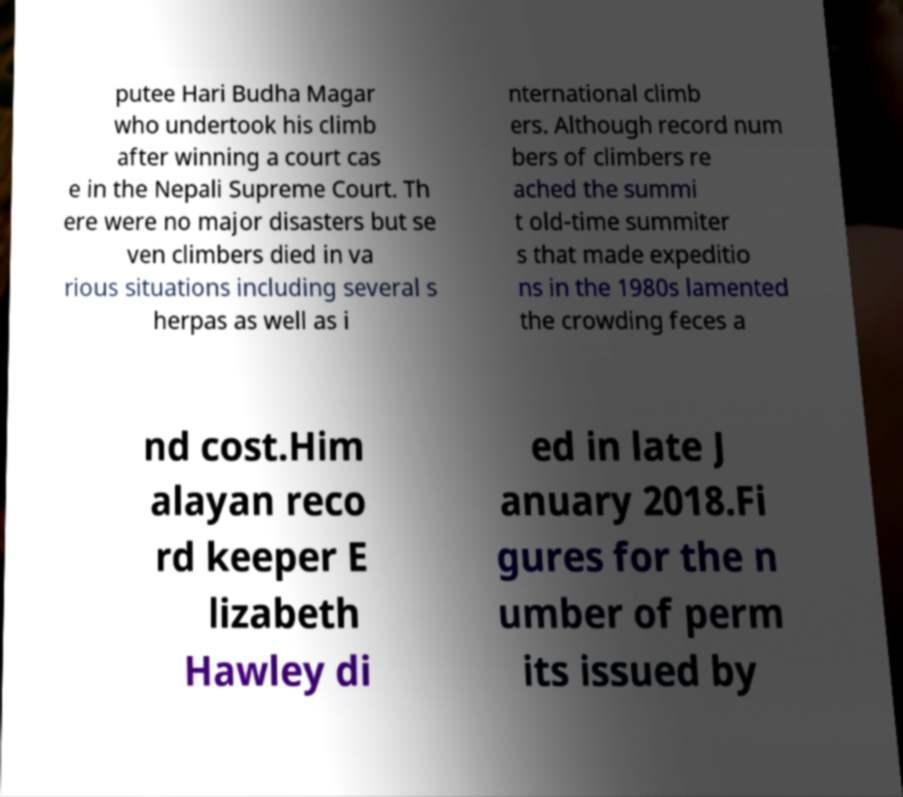What messages or text are displayed in this image? I need them in a readable, typed format. putee Hari Budha Magar who undertook his climb after winning a court cas e in the Nepali Supreme Court. Th ere were no major disasters but se ven climbers died in va rious situations including several s herpas as well as i nternational climb ers. Although record num bers of climbers re ached the summi t old-time summiter s that made expeditio ns in the 1980s lamented the crowding feces a nd cost.Him alayan reco rd keeper E lizabeth Hawley di ed in late J anuary 2018.Fi gures for the n umber of perm its issued by 